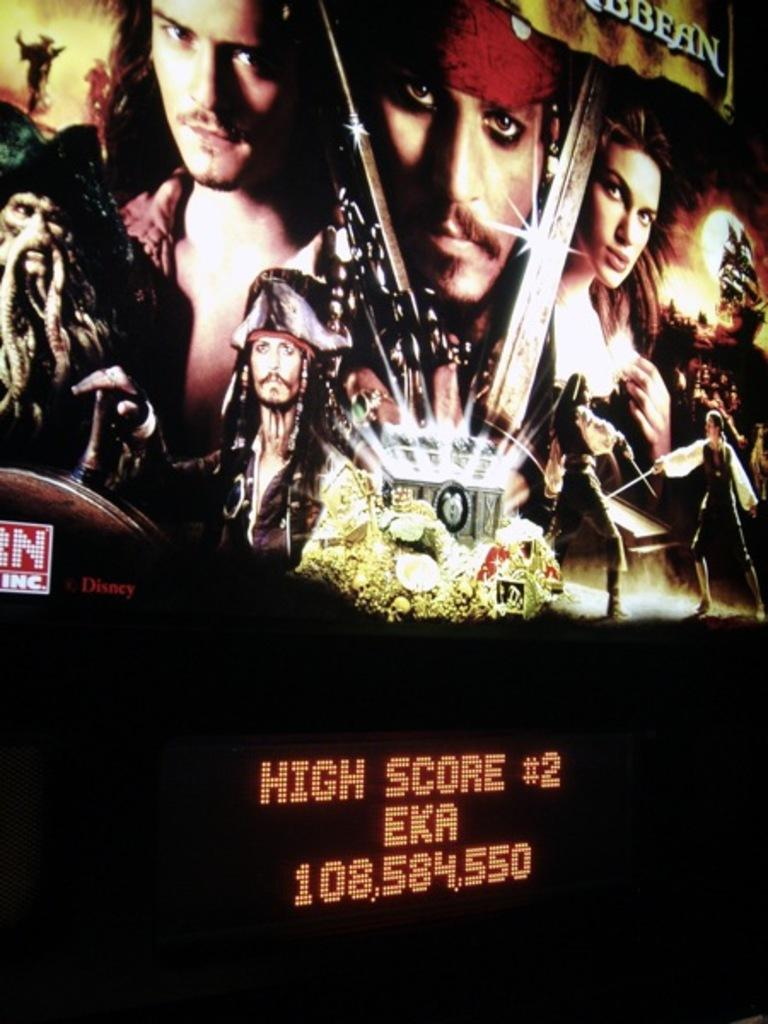Provide a one-sentence caption for the provided image. Movie bilboard for the movie "The Pirates of Carribean". 